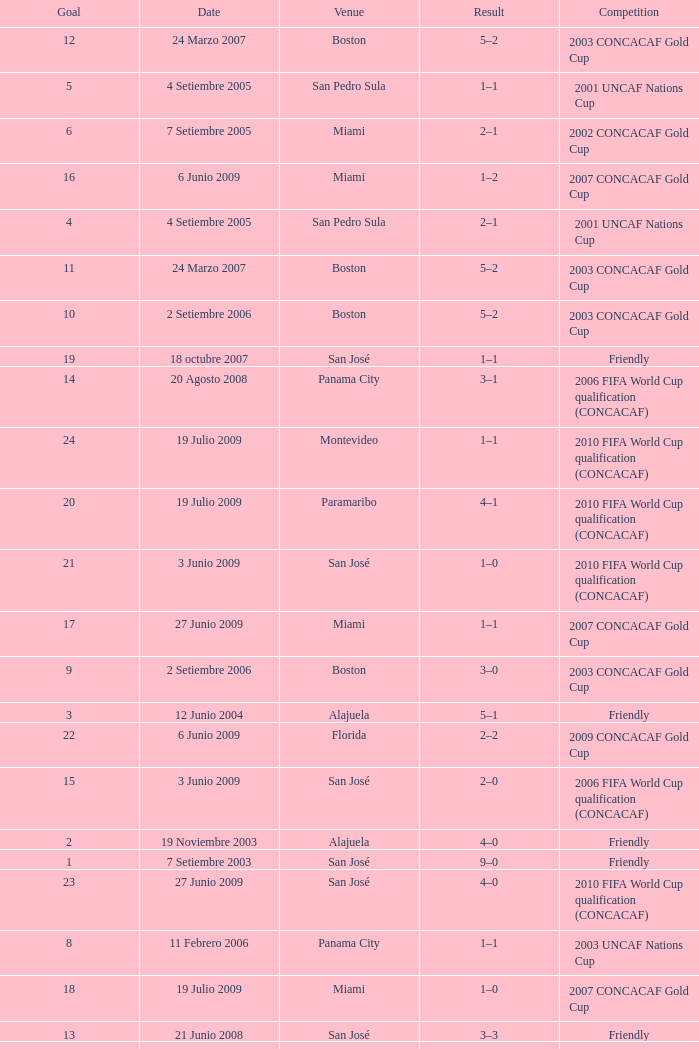At the venue of panama city, on 11 Febrero 2006, how many goals were scored? 1.0. 